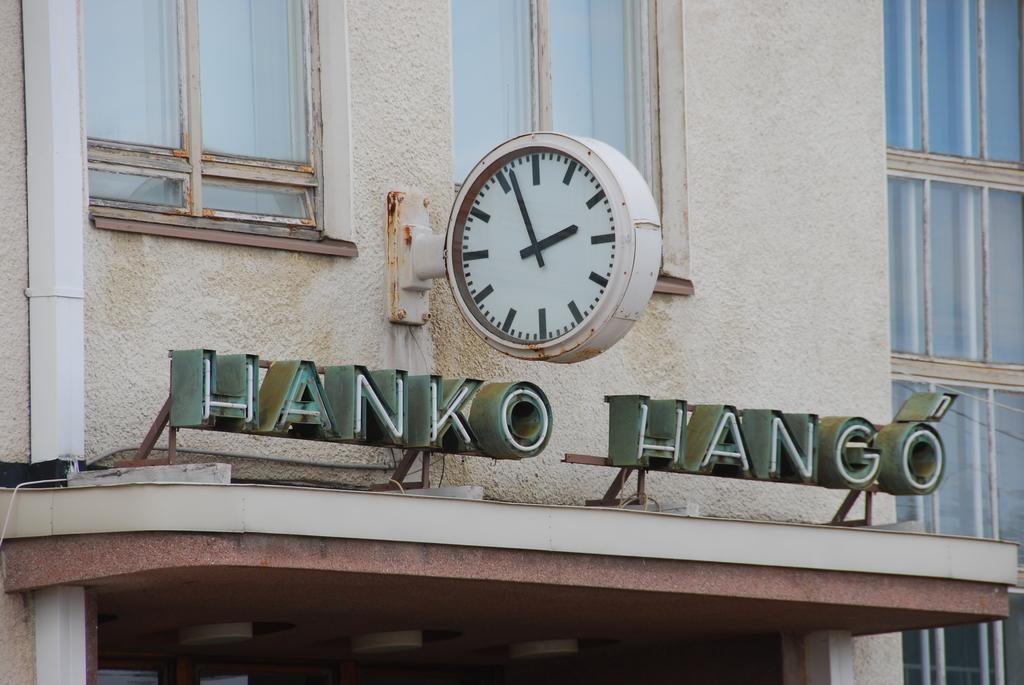<image>
Share a concise interpretation of the image provided. the outside of a building with a clock above the name 'hanko hango' 